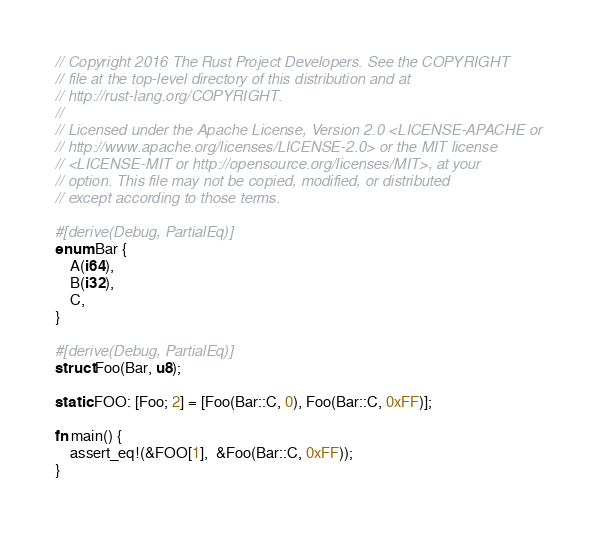<code> <loc_0><loc_0><loc_500><loc_500><_Rust_>// Copyright 2016 The Rust Project Developers. See the COPYRIGHT
// file at the top-level directory of this distribution and at
// http://rust-lang.org/COPYRIGHT.
//
// Licensed under the Apache License, Version 2.0 <LICENSE-APACHE or
// http://www.apache.org/licenses/LICENSE-2.0> or the MIT license
// <LICENSE-MIT or http://opensource.org/licenses/MIT>, at your
// option. This file may not be copied, modified, or distributed
// except according to those terms.

#[derive(Debug, PartialEq)]
enum Bar {
    A(i64),
    B(i32),
    C,
}

#[derive(Debug, PartialEq)]
struct Foo(Bar, u8);

static FOO: [Foo; 2] = [Foo(Bar::C, 0), Foo(Bar::C, 0xFF)];

fn main() {
    assert_eq!(&FOO[1],  &Foo(Bar::C, 0xFF));
}
</code> 